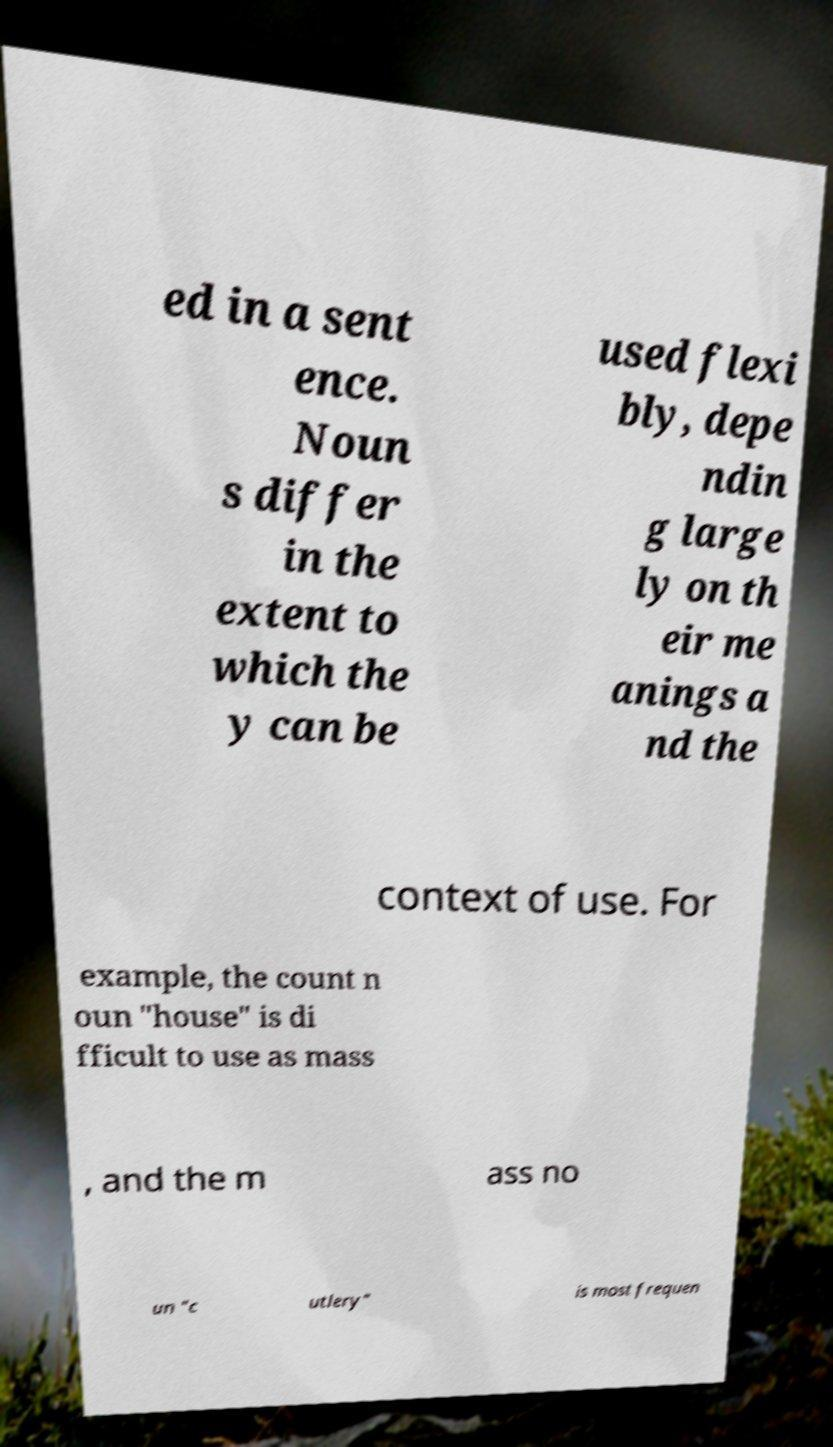For documentation purposes, I need the text within this image transcribed. Could you provide that? ed in a sent ence. Noun s differ in the extent to which the y can be used flexi bly, depe ndin g large ly on th eir me anings a nd the context of use. For example, the count n oun "house" is di fficult to use as mass , and the m ass no un "c utlery" is most frequen 